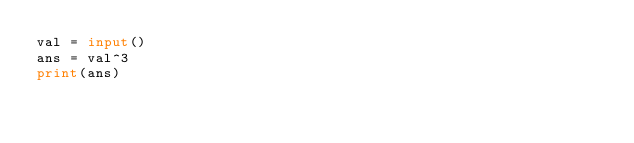Convert code to text. <code><loc_0><loc_0><loc_500><loc_500><_Python_>val = input()
ans = val^3
print(ans)</code> 